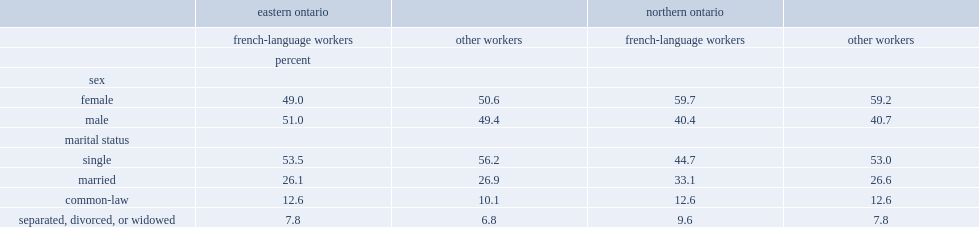What percent of the agri-food workforce in northern ontario are made up by female workers? 59.7 59.2. Which group of workers in northern ontario were more likely to be married? french-language workers or non-francophone workers? French-language workers. 